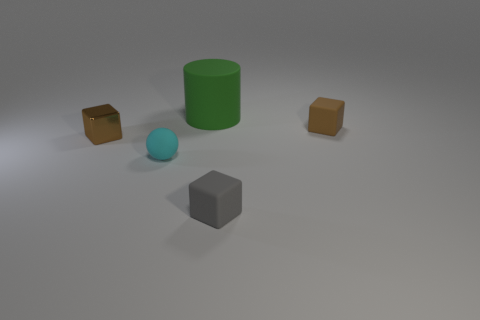Add 4 green shiny cylinders. How many objects exist? 9 Subtract all cubes. How many objects are left? 2 Subtract all brown metal cubes. Subtract all purple shiny blocks. How many objects are left? 4 Add 2 small brown cubes. How many small brown cubes are left? 4 Add 2 big rubber cylinders. How many big rubber cylinders exist? 3 Subtract 0 red spheres. How many objects are left? 5 